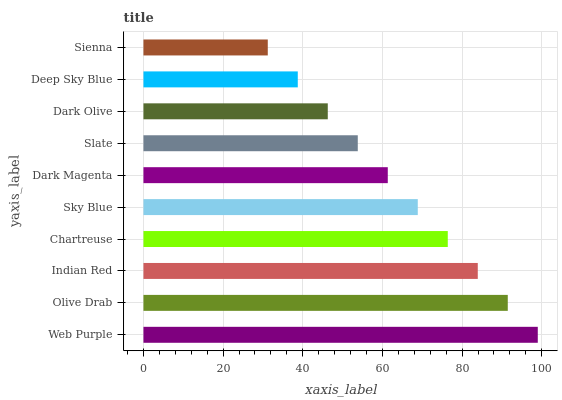Is Sienna the minimum?
Answer yes or no. Yes. Is Web Purple the maximum?
Answer yes or no. Yes. Is Olive Drab the minimum?
Answer yes or no. No. Is Olive Drab the maximum?
Answer yes or no. No. Is Web Purple greater than Olive Drab?
Answer yes or no. Yes. Is Olive Drab less than Web Purple?
Answer yes or no. Yes. Is Olive Drab greater than Web Purple?
Answer yes or no. No. Is Web Purple less than Olive Drab?
Answer yes or no. No. Is Sky Blue the high median?
Answer yes or no. Yes. Is Dark Magenta the low median?
Answer yes or no. Yes. Is Indian Red the high median?
Answer yes or no. No. Is Dark Olive the low median?
Answer yes or no. No. 